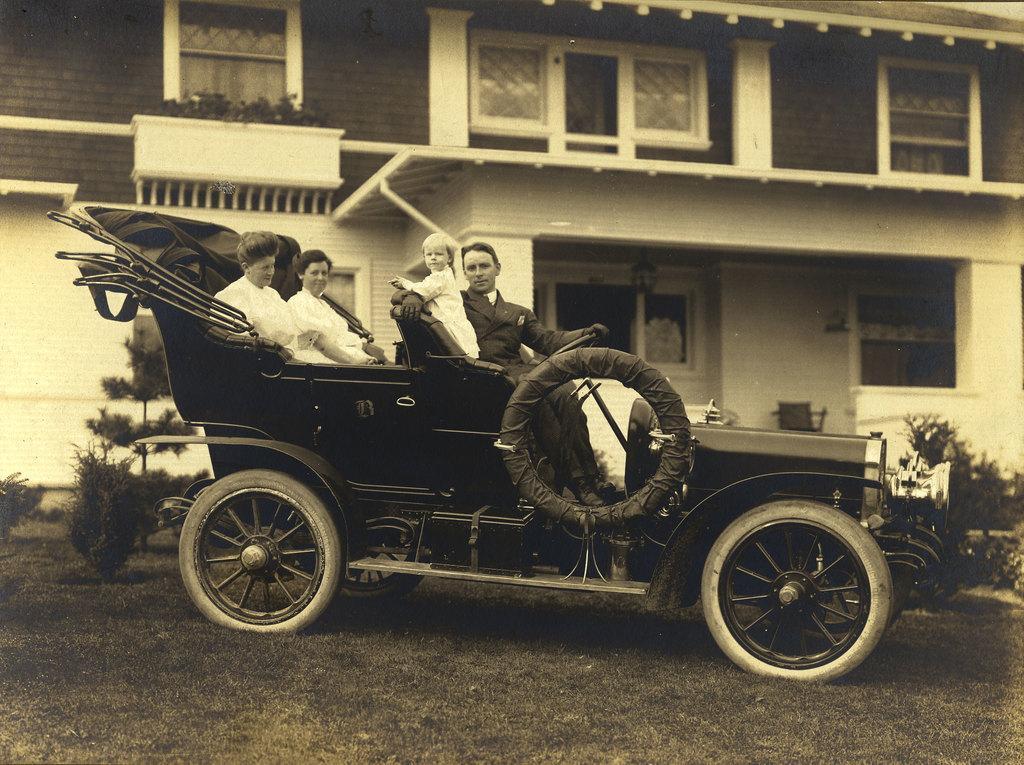Can you describe this image briefly? This picture is clicked outside the room. Here, we see four people are sitting on a four wheeler which is parked in the ground or in the garden. The man sitting in front seat is holding steering wheel and beside her, baby is standing on the seat and behind them, we see two women sitting sitting on the seat. Behind the four wheeler, we see shrubs and plants and behind that, we see the building and also the windows and doors of that house. 